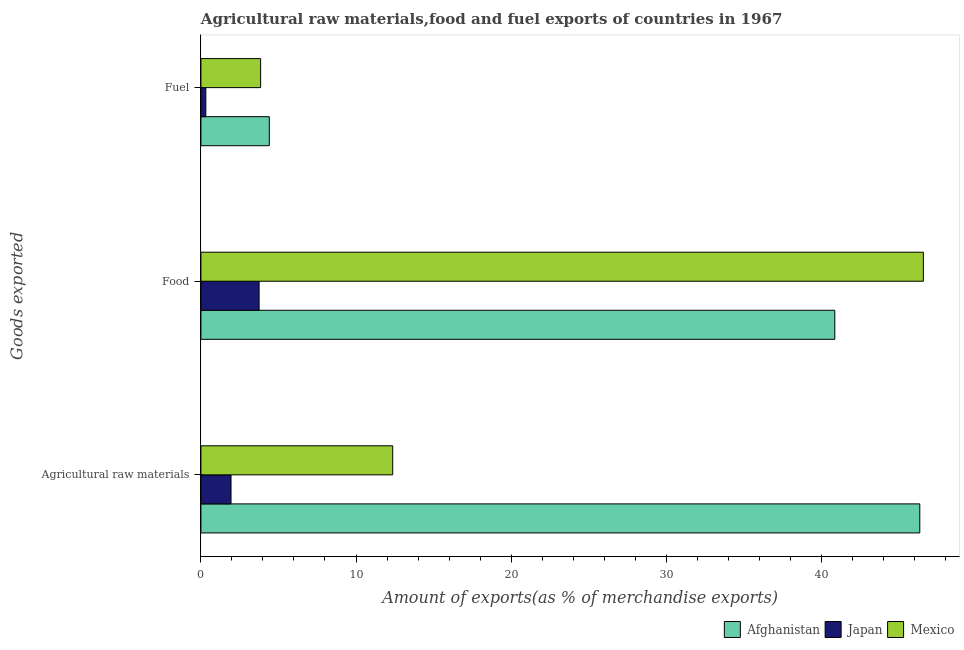How many different coloured bars are there?
Offer a very short reply. 3. Are the number of bars per tick equal to the number of legend labels?
Provide a succinct answer. Yes. How many bars are there on the 1st tick from the top?
Keep it short and to the point. 3. How many bars are there on the 1st tick from the bottom?
Your answer should be very brief. 3. What is the label of the 3rd group of bars from the top?
Your answer should be very brief. Agricultural raw materials. What is the percentage of raw materials exports in Mexico?
Provide a succinct answer. 12.37. Across all countries, what is the maximum percentage of raw materials exports?
Make the answer very short. 46.36. Across all countries, what is the minimum percentage of raw materials exports?
Keep it short and to the point. 1.94. In which country was the percentage of food exports minimum?
Offer a terse response. Japan. What is the total percentage of fuel exports in the graph?
Offer a very short reply. 8.58. What is the difference between the percentage of raw materials exports in Afghanistan and that in Japan?
Provide a short and direct response. 44.41. What is the difference between the percentage of fuel exports in Mexico and the percentage of food exports in Japan?
Your answer should be compact. 0.1. What is the average percentage of raw materials exports per country?
Make the answer very short. 20.22. What is the difference between the percentage of raw materials exports and percentage of fuel exports in Mexico?
Provide a succinct answer. 8.52. In how many countries, is the percentage of food exports greater than 26 %?
Your answer should be very brief. 2. What is the ratio of the percentage of fuel exports in Japan to that in Mexico?
Offer a very short reply. 0.08. Is the percentage of fuel exports in Japan less than that in Mexico?
Offer a very short reply. Yes. What is the difference between the highest and the second highest percentage of food exports?
Give a very brief answer. 5.71. What is the difference between the highest and the lowest percentage of fuel exports?
Your answer should be very brief. 4.09. In how many countries, is the percentage of food exports greater than the average percentage of food exports taken over all countries?
Provide a succinct answer. 2. Is the sum of the percentage of raw materials exports in Japan and Mexico greater than the maximum percentage of fuel exports across all countries?
Keep it short and to the point. Yes. What does the 3rd bar from the top in Agricultural raw materials represents?
Provide a short and direct response. Afghanistan. What does the 1st bar from the bottom in Fuel represents?
Your answer should be very brief. Afghanistan. How many bars are there?
Your answer should be very brief. 9. Does the graph contain any zero values?
Offer a terse response. No. Does the graph contain grids?
Offer a terse response. No. Where does the legend appear in the graph?
Offer a very short reply. Bottom right. How many legend labels are there?
Keep it short and to the point. 3. How are the legend labels stacked?
Give a very brief answer. Horizontal. What is the title of the graph?
Keep it short and to the point. Agricultural raw materials,food and fuel exports of countries in 1967. Does "Palau" appear as one of the legend labels in the graph?
Provide a succinct answer. No. What is the label or title of the X-axis?
Provide a succinct answer. Amount of exports(as % of merchandise exports). What is the label or title of the Y-axis?
Provide a succinct answer. Goods exported. What is the Amount of exports(as % of merchandise exports) of Afghanistan in Agricultural raw materials?
Offer a terse response. 46.36. What is the Amount of exports(as % of merchandise exports) in Japan in Agricultural raw materials?
Make the answer very short. 1.94. What is the Amount of exports(as % of merchandise exports) in Mexico in Agricultural raw materials?
Give a very brief answer. 12.37. What is the Amount of exports(as % of merchandise exports) in Afghanistan in Food?
Offer a terse response. 40.88. What is the Amount of exports(as % of merchandise exports) in Japan in Food?
Give a very brief answer. 3.75. What is the Amount of exports(as % of merchandise exports) of Mexico in Food?
Ensure brevity in your answer.  46.59. What is the Amount of exports(as % of merchandise exports) of Afghanistan in Fuel?
Ensure brevity in your answer.  4.41. What is the Amount of exports(as % of merchandise exports) of Japan in Fuel?
Ensure brevity in your answer.  0.32. What is the Amount of exports(as % of merchandise exports) of Mexico in Fuel?
Offer a very short reply. 3.85. Across all Goods exported, what is the maximum Amount of exports(as % of merchandise exports) of Afghanistan?
Ensure brevity in your answer.  46.36. Across all Goods exported, what is the maximum Amount of exports(as % of merchandise exports) of Japan?
Your answer should be very brief. 3.75. Across all Goods exported, what is the maximum Amount of exports(as % of merchandise exports) of Mexico?
Your answer should be very brief. 46.59. Across all Goods exported, what is the minimum Amount of exports(as % of merchandise exports) of Afghanistan?
Offer a very short reply. 4.41. Across all Goods exported, what is the minimum Amount of exports(as % of merchandise exports) of Japan?
Ensure brevity in your answer.  0.32. Across all Goods exported, what is the minimum Amount of exports(as % of merchandise exports) of Mexico?
Your response must be concise. 3.85. What is the total Amount of exports(as % of merchandise exports) in Afghanistan in the graph?
Offer a terse response. 91.64. What is the total Amount of exports(as % of merchandise exports) of Japan in the graph?
Ensure brevity in your answer.  6.01. What is the total Amount of exports(as % of merchandise exports) in Mexico in the graph?
Offer a very short reply. 62.8. What is the difference between the Amount of exports(as % of merchandise exports) of Afghanistan in Agricultural raw materials and that in Food?
Your answer should be very brief. 5.48. What is the difference between the Amount of exports(as % of merchandise exports) in Japan in Agricultural raw materials and that in Food?
Your answer should be very brief. -1.81. What is the difference between the Amount of exports(as % of merchandise exports) of Mexico in Agricultural raw materials and that in Food?
Provide a succinct answer. -34.22. What is the difference between the Amount of exports(as % of merchandise exports) of Afghanistan in Agricultural raw materials and that in Fuel?
Your response must be concise. 41.95. What is the difference between the Amount of exports(as % of merchandise exports) in Japan in Agricultural raw materials and that in Fuel?
Provide a short and direct response. 1.63. What is the difference between the Amount of exports(as % of merchandise exports) of Mexico in Agricultural raw materials and that in Fuel?
Provide a short and direct response. 8.52. What is the difference between the Amount of exports(as % of merchandise exports) in Afghanistan in Food and that in Fuel?
Your answer should be compact. 36.47. What is the difference between the Amount of exports(as % of merchandise exports) of Japan in Food and that in Fuel?
Keep it short and to the point. 3.44. What is the difference between the Amount of exports(as % of merchandise exports) of Mexico in Food and that in Fuel?
Provide a short and direct response. 42.74. What is the difference between the Amount of exports(as % of merchandise exports) of Afghanistan in Agricultural raw materials and the Amount of exports(as % of merchandise exports) of Japan in Food?
Your response must be concise. 42.6. What is the difference between the Amount of exports(as % of merchandise exports) in Afghanistan in Agricultural raw materials and the Amount of exports(as % of merchandise exports) in Mexico in Food?
Your answer should be compact. -0.23. What is the difference between the Amount of exports(as % of merchandise exports) of Japan in Agricultural raw materials and the Amount of exports(as % of merchandise exports) of Mexico in Food?
Your answer should be very brief. -44.64. What is the difference between the Amount of exports(as % of merchandise exports) in Afghanistan in Agricultural raw materials and the Amount of exports(as % of merchandise exports) in Japan in Fuel?
Your answer should be compact. 46.04. What is the difference between the Amount of exports(as % of merchandise exports) of Afghanistan in Agricultural raw materials and the Amount of exports(as % of merchandise exports) of Mexico in Fuel?
Your answer should be compact. 42.51. What is the difference between the Amount of exports(as % of merchandise exports) in Japan in Agricultural raw materials and the Amount of exports(as % of merchandise exports) in Mexico in Fuel?
Your answer should be compact. -1.91. What is the difference between the Amount of exports(as % of merchandise exports) of Afghanistan in Food and the Amount of exports(as % of merchandise exports) of Japan in Fuel?
Offer a very short reply. 40.56. What is the difference between the Amount of exports(as % of merchandise exports) of Afghanistan in Food and the Amount of exports(as % of merchandise exports) of Mexico in Fuel?
Your answer should be compact. 37.03. What is the difference between the Amount of exports(as % of merchandise exports) of Japan in Food and the Amount of exports(as % of merchandise exports) of Mexico in Fuel?
Give a very brief answer. -0.1. What is the average Amount of exports(as % of merchandise exports) of Afghanistan per Goods exported?
Offer a very short reply. 30.55. What is the average Amount of exports(as % of merchandise exports) of Japan per Goods exported?
Make the answer very short. 2. What is the average Amount of exports(as % of merchandise exports) of Mexico per Goods exported?
Your answer should be compact. 20.93. What is the difference between the Amount of exports(as % of merchandise exports) in Afghanistan and Amount of exports(as % of merchandise exports) in Japan in Agricultural raw materials?
Your answer should be very brief. 44.41. What is the difference between the Amount of exports(as % of merchandise exports) of Afghanistan and Amount of exports(as % of merchandise exports) of Mexico in Agricultural raw materials?
Offer a terse response. 33.99. What is the difference between the Amount of exports(as % of merchandise exports) of Japan and Amount of exports(as % of merchandise exports) of Mexico in Agricultural raw materials?
Ensure brevity in your answer.  -10.43. What is the difference between the Amount of exports(as % of merchandise exports) in Afghanistan and Amount of exports(as % of merchandise exports) in Japan in Food?
Keep it short and to the point. 37.12. What is the difference between the Amount of exports(as % of merchandise exports) of Afghanistan and Amount of exports(as % of merchandise exports) of Mexico in Food?
Provide a succinct answer. -5.71. What is the difference between the Amount of exports(as % of merchandise exports) in Japan and Amount of exports(as % of merchandise exports) in Mexico in Food?
Provide a succinct answer. -42.83. What is the difference between the Amount of exports(as % of merchandise exports) of Afghanistan and Amount of exports(as % of merchandise exports) of Japan in Fuel?
Ensure brevity in your answer.  4.09. What is the difference between the Amount of exports(as % of merchandise exports) of Afghanistan and Amount of exports(as % of merchandise exports) of Mexico in Fuel?
Your response must be concise. 0.56. What is the difference between the Amount of exports(as % of merchandise exports) in Japan and Amount of exports(as % of merchandise exports) in Mexico in Fuel?
Your answer should be very brief. -3.53. What is the ratio of the Amount of exports(as % of merchandise exports) of Afghanistan in Agricultural raw materials to that in Food?
Keep it short and to the point. 1.13. What is the ratio of the Amount of exports(as % of merchandise exports) in Japan in Agricultural raw materials to that in Food?
Your response must be concise. 0.52. What is the ratio of the Amount of exports(as % of merchandise exports) in Mexico in Agricultural raw materials to that in Food?
Keep it short and to the point. 0.27. What is the ratio of the Amount of exports(as % of merchandise exports) of Afghanistan in Agricultural raw materials to that in Fuel?
Offer a very short reply. 10.51. What is the ratio of the Amount of exports(as % of merchandise exports) of Japan in Agricultural raw materials to that in Fuel?
Offer a terse response. 6.14. What is the ratio of the Amount of exports(as % of merchandise exports) in Mexico in Agricultural raw materials to that in Fuel?
Your response must be concise. 3.21. What is the ratio of the Amount of exports(as % of merchandise exports) of Afghanistan in Food to that in Fuel?
Provide a short and direct response. 9.27. What is the ratio of the Amount of exports(as % of merchandise exports) in Japan in Food to that in Fuel?
Your answer should be very brief. 11.86. What is the ratio of the Amount of exports(as % of merchandise exports) in Mexico in Food to that in Fuel?
Keep it short and to the point. 12.1. What is the difference between the highest and the second highest Amount of exports(as % of merchandise exports) of Afghanistan?
Keep it short and to the point. 5.48. What is the difference between the highest and the second highest Amount of exports(as % of merchandise exports) of Japan?
Offer a very short reply. 1.81. What is the difference between the highest and the second highest Amount of exports(as % of merchandise exports) of Mexico?
Give a very brief answer. 34.22. What is the difference between the highest and the lowest Amount of exports(as % of merchandise exports) in Afghanistan?
Give a very brief answer. 41.95. What is the difference between the highest and the lowest Amount of exports(as % of merchandise exports) of Japan?
Offer a very short reply. 3.44. What is the difference between the highest and the lowest Amount of exports(as % of merchandise exports) in Mexico?
Give a very brief answer. 42.74. 